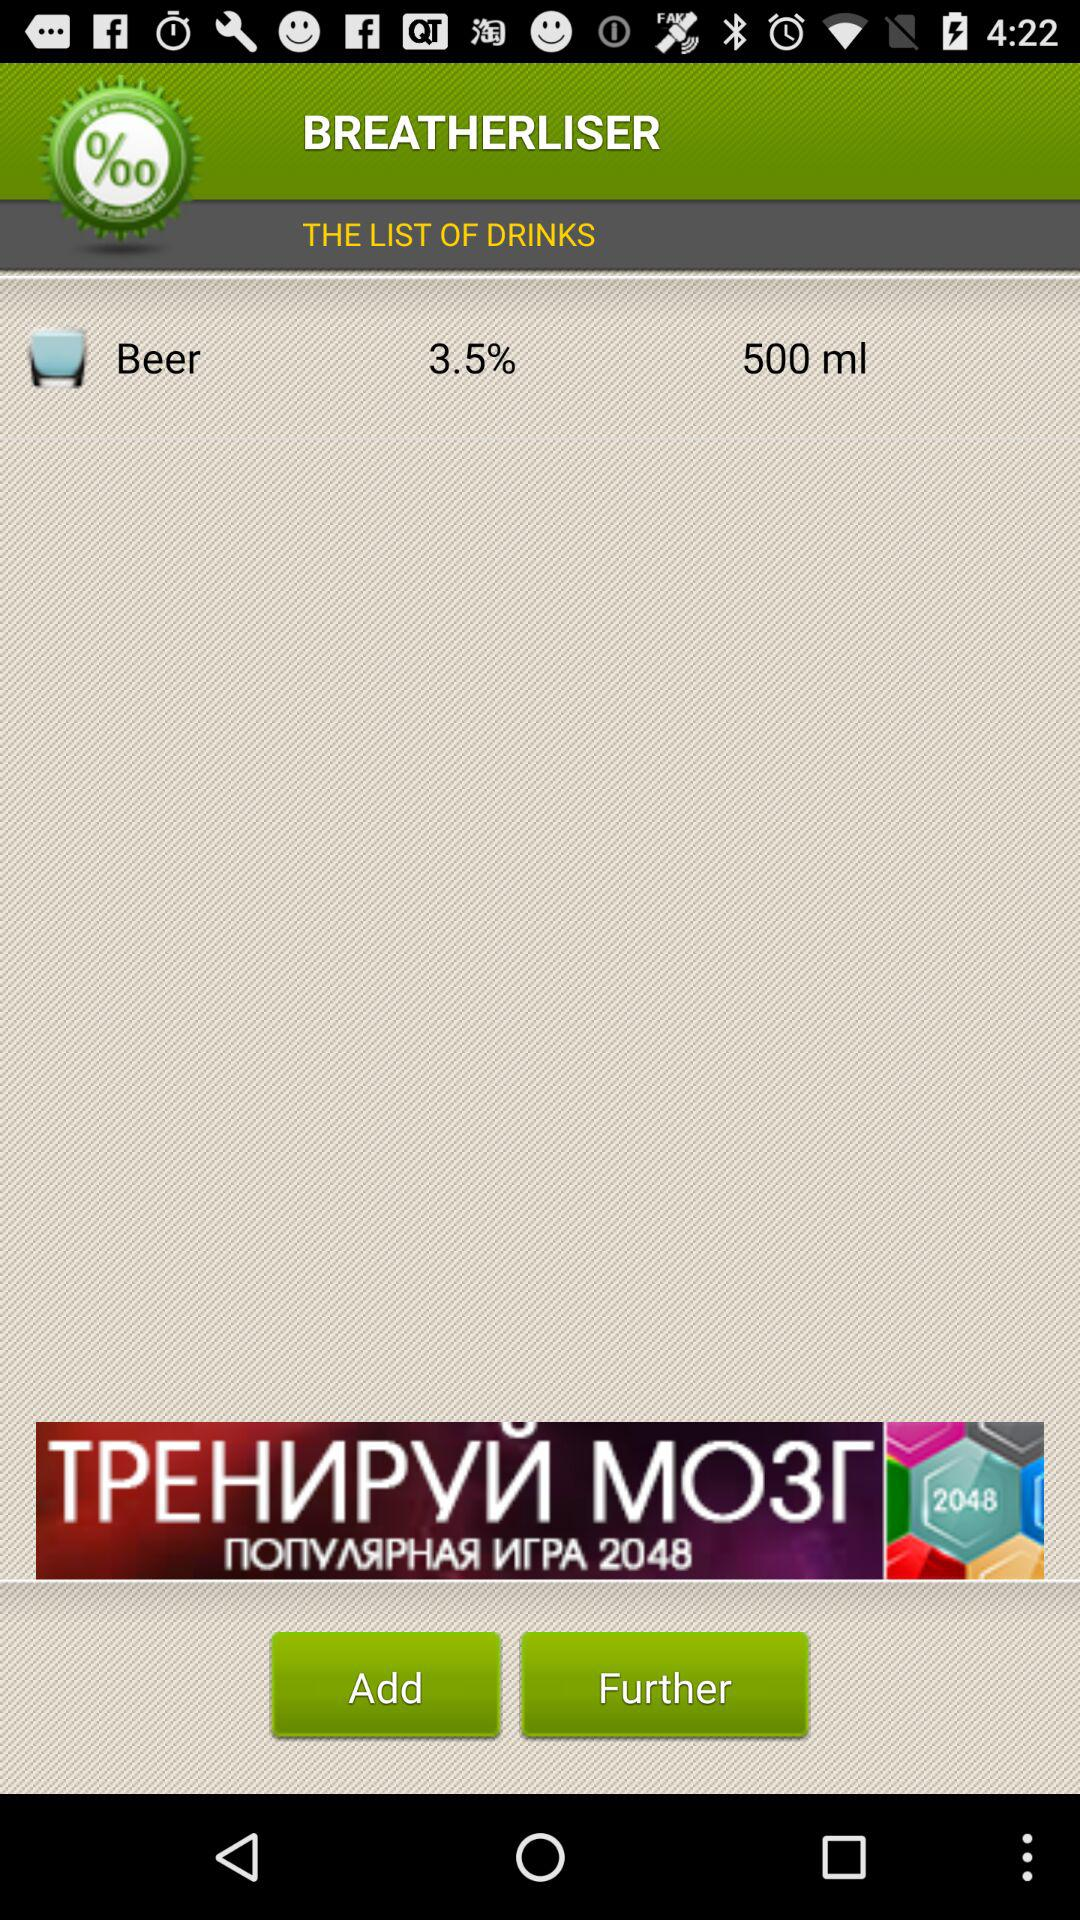What is the name of the drink? The name of the drink is "Beer". 